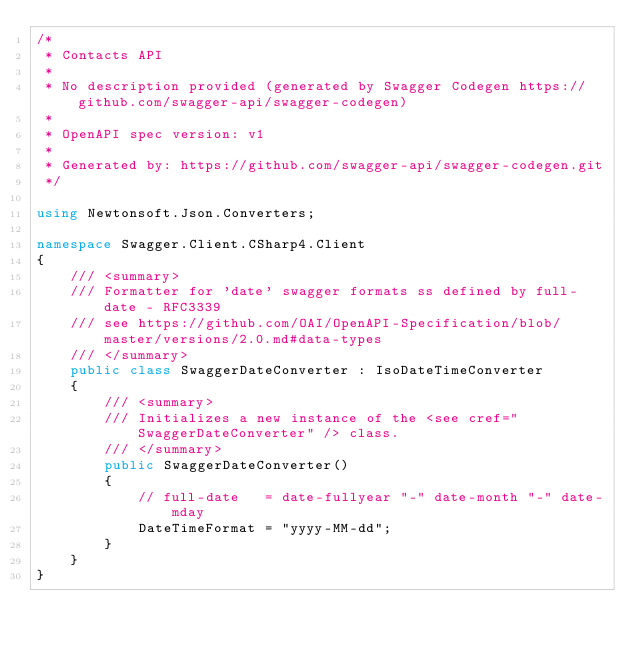<code> <loc_0><loc_0><loc_500><loc_500><_C#_>/* 
 * Contacts API
 *
 * No description provided (generated by Swagger Codegen https://github.com/swagger-api/swagger-codegen)
 *
 * OpenAPI spec version: v1
 * 
 * Generated by: https://github.com/swagger-api/swagger-codegen.git
 */

using Newtonsoft.Json.Converters;

namespace Swagger.Client.CSharp4.Client
{
    /// <summary>
    /// Formatter for 'date' swagger formats ss defined by full-date - RFC3339
    /// see https://github.com/OAI/OpenAPI-Specification/blob/master/versions/2.0.md#data-types
    /// </summary>
    public class SwaggerDateConverter : IsoDateTimeConverter
    {
        /// <summary>
        /// Initializes a new instance of the <see cref="SwaggerDateConverter" /> class.
        /// </summary>
        public SwaggerDateConverter()
        {
            // full-date   = date-fullyear "-" date-month "-" date-mday
            DateTimeFormat = "yyyy-MM-dd";
        }
    }
}
</code> 